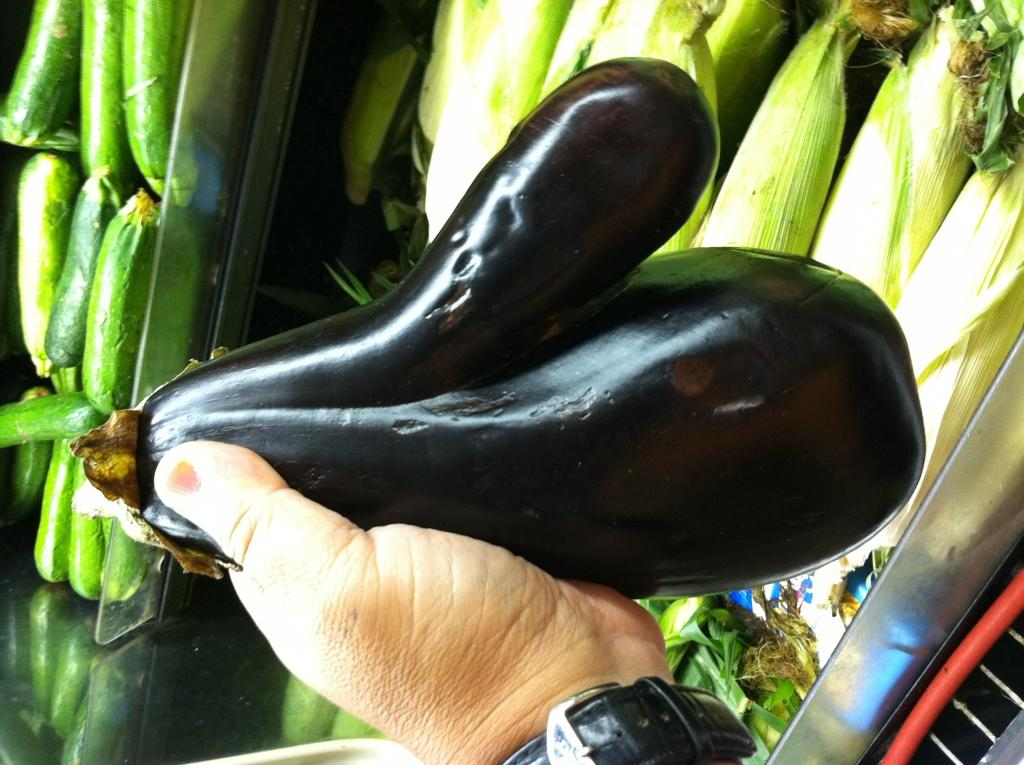What is the person holding in the image? There is a person's hand holding an eggplant in the image. What type of vegetables can be seen in the background of the image? There are cucumbers and corns in the background of the image. How are the cucumbers and corns arranged in the image? The cucumbers and corns are kept in racks in the background of the image. What type of pencil can be seen in the image? There is no pencil present in the image. Is there a match being used to light a candle in the image? There is no match or candle present in the image. 